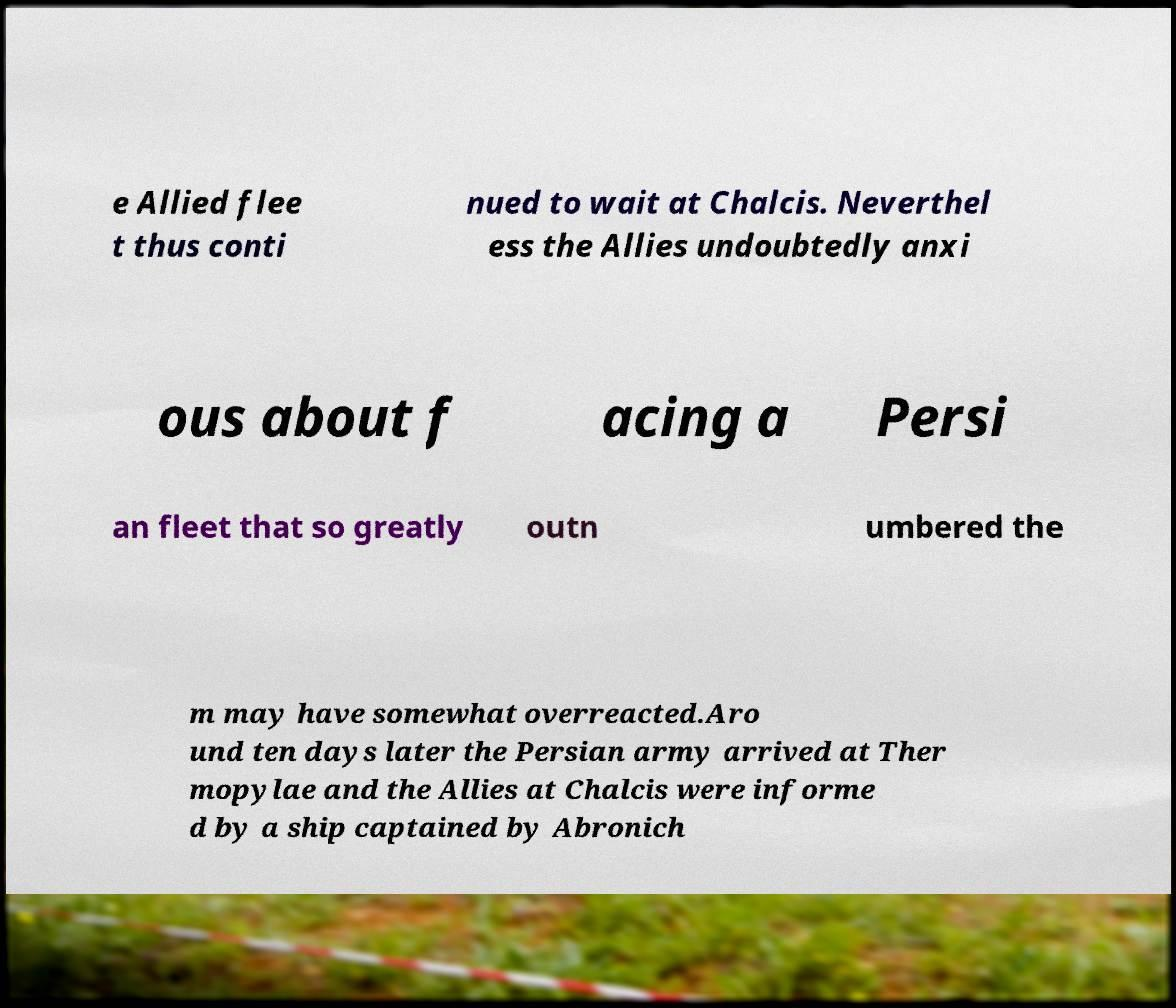Please read and relay the text visible in this image. What does it say? e Allied flee t thus conti nued to wait at Chalcis. Neverthel ess the Allies undoubtedly anxi ous about f acing a Persi an fleet that so greatly outn umbered the m may have somewhat overreacted.Aro und ten days later the Persian army arrived at Ther mopylae and the Allies at Chalcis were informe d by a ship captained by Abronich 